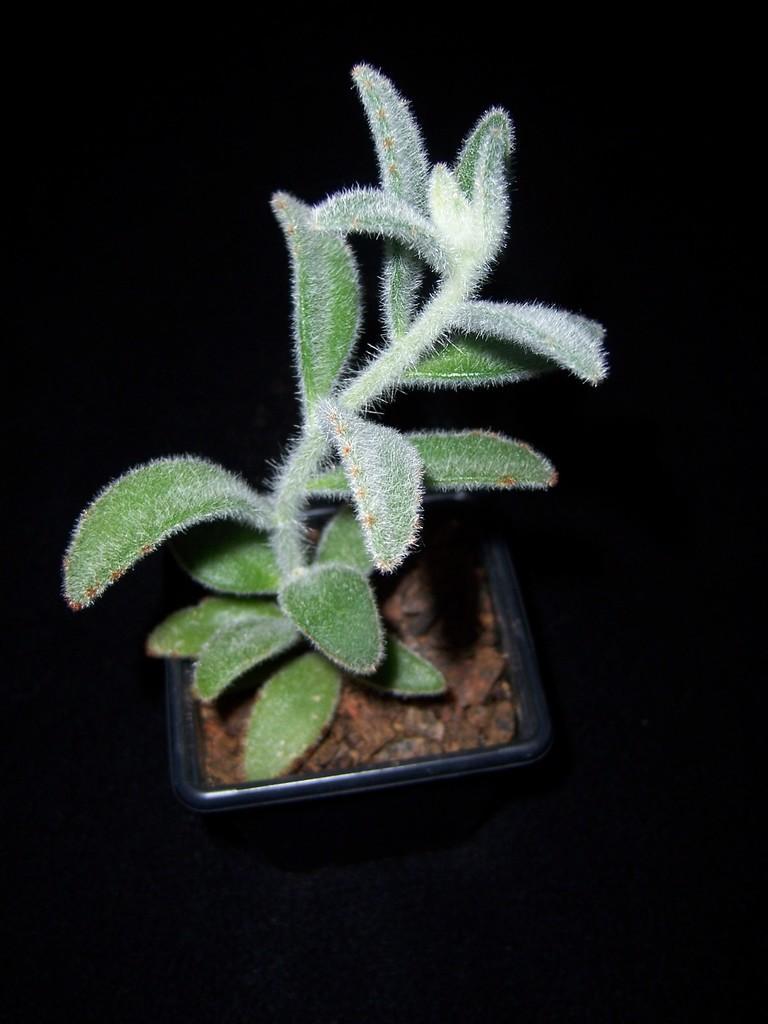In one or two sentences, can you explain what this image depicts? In this picture we can see a house plant and in the background we can see it is dark. 